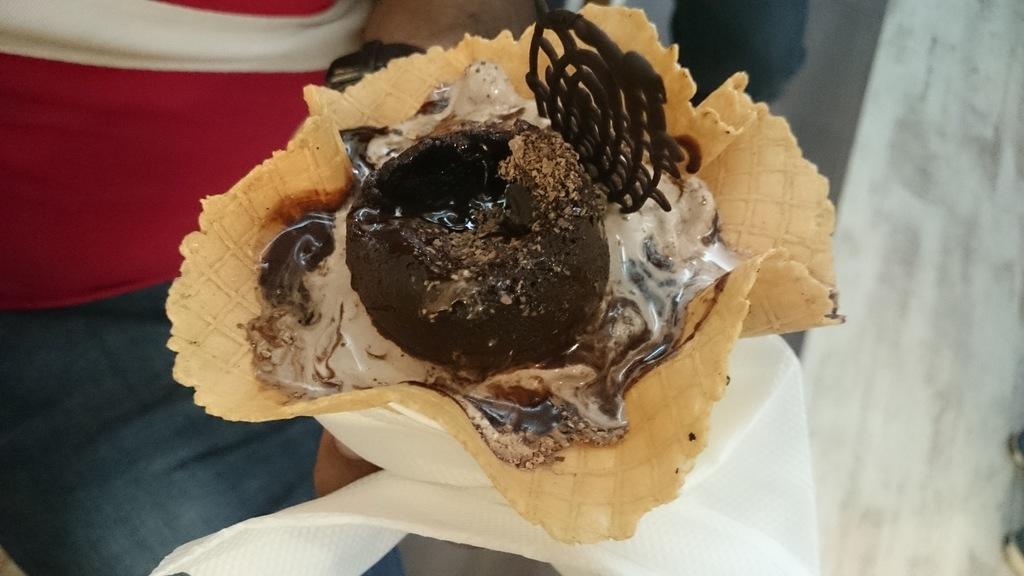Describe this image in one or two sentences. In this image I can see a hand of a person and here I can see an ice cream. I can see colour of this ice cream is white, black and green. I can also see few tissue papers. 